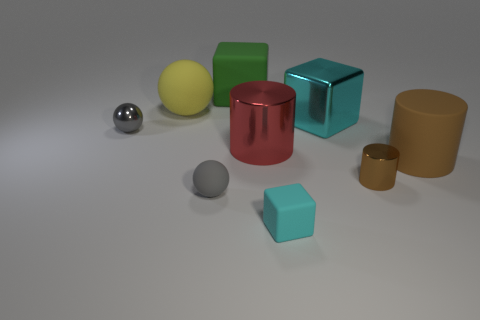Add 1 large gray matte things. How many objects exist? 10 Subtract all blocks. How many objects are left? 6 Subtract all cylinders. Subtract all big matte cylinders. How many objects are left? 5 Add 3 big cyan things. How many big cyan things are left? 4 Add 7 cubes. How many cubes exist? 10 Subtract 1 yellow balls. How many objects are left? 8 